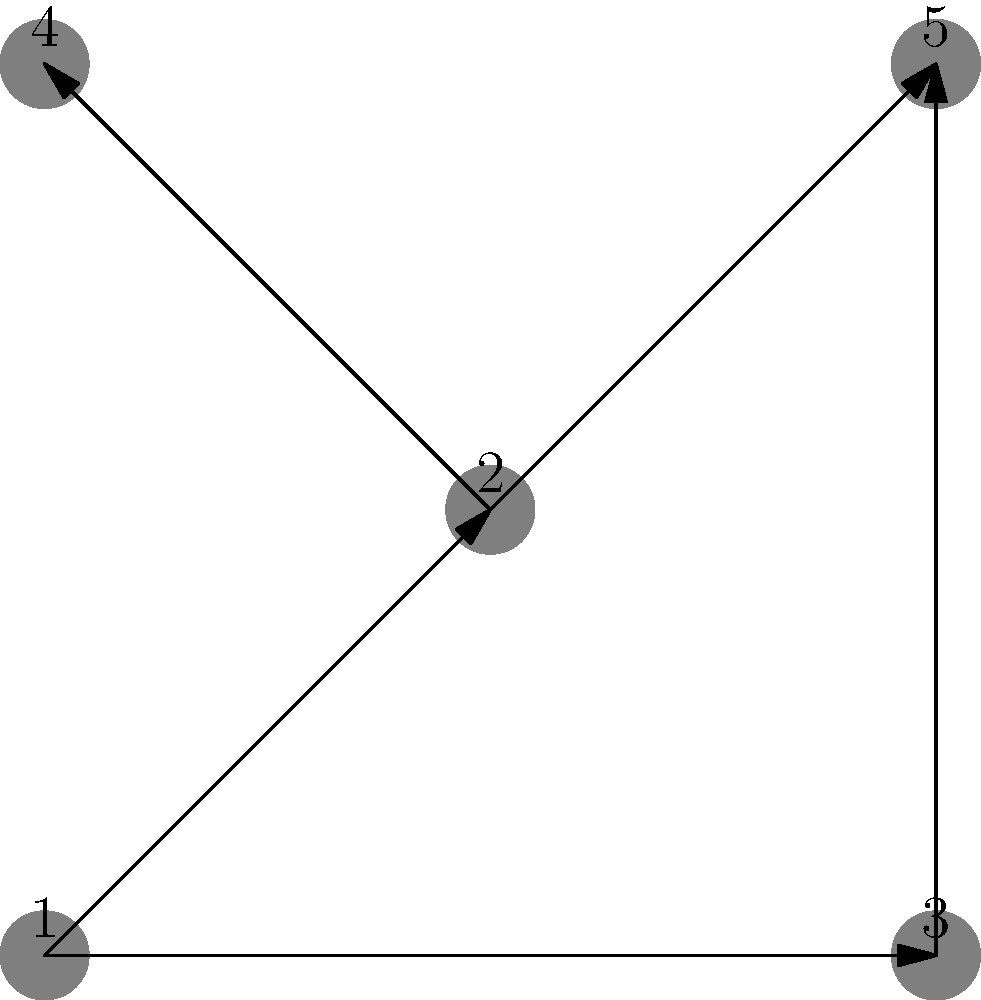In the directed graph representing a simplified food web, vertices represent species and edges represent energy flow from prey to predator. What is the trophic level of species 5? To determine the trophic level of species 5, we need to analyze the longest path from a producer (species with no incoming edges) to species 5. Let's proceed step-by-step:

1. Identify the producer(s):
   Species 1 has no incoming edges, so it's the only producer (trophic level 1).

2. Trace the paths from the producer to species 5:
   Path 1: 1 → 2 → 5
   Path 2: 1 → 2 → 4 → 5

3. Count the number of edges in each path:
   Path 1: 2 edges
   Path 2: 3 edges

4. The trophic level is determined by the longest path plus one:
   Longest path has 3 edges, so the trophic level of species 5 is 3 + 1 = 4.

Therefore, species 5 is at trophic level 4, making it a tertiary consumer in this food web.
Answer: 4 